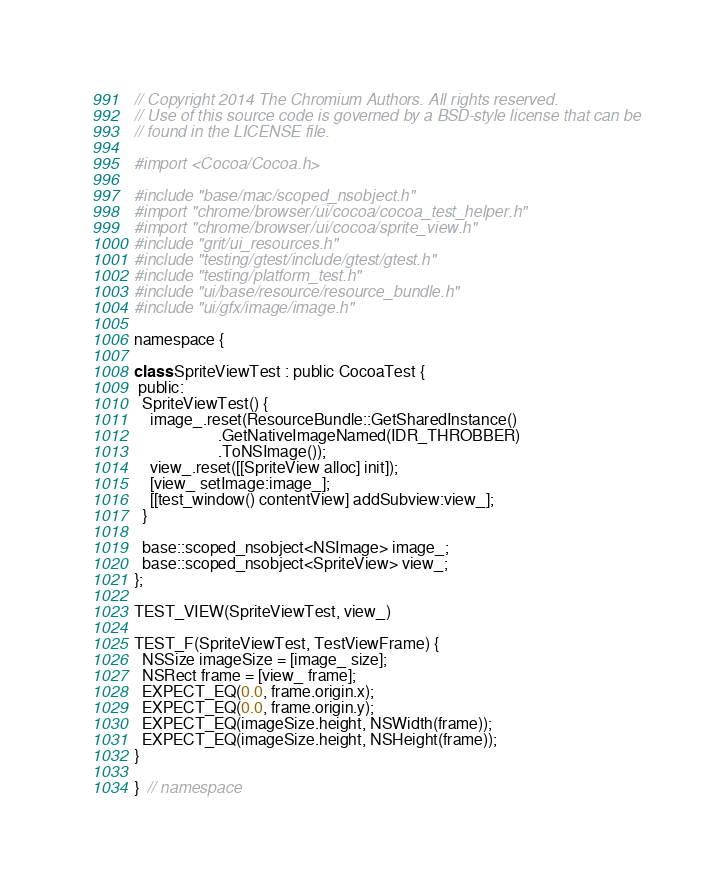Convert code to text. <code><loc_0><loc_0><loc_500><loc_500><_ObjectiveC_>// Copyright 2014 The Chromium Authors. All rights reserved.
// Use of this source code is governed by a BSD-style license that can be
// found in the LICENSE file.

#import <Cocoa/Cocoa.h>

#include "base/mac/scoped_nsobject.h"
#import "chrome/browser/ui/cocoa/cocoa_test_helper.h"
#import "chrome/browser/ui/cocoa/sprite_view.h"
#include "grit/ui_resources.h"
#include "testing/gtest/include/gtest/gtest.h"
#include "testing/platform_test.h"
#include "ui/base/resource/resource_bundle.h"
#include "ui/gfx/image/image.h"

namespace {

class SpriteViewTest : public CocoaTest {
 public:
  SpriteViewTest() {
    image_.reset(ResourceBundle::GetSharedInstance()
                     .GetNativeImageNamed(IDR_THROBBER)
                     .ToNSImage());
    view_.reset([[SpriteView alloc] init]);
    [view_ setImage:image_];
    [[test_window() contentView] addSubview:view_];
  }

  base::scoped_nsobject<NSImage> image_;
  base::scoped_nsobject<SpriteView> view_;
};

TEST_VIEW(SpriteViewTest, view_)

TEST_F(SpriteViewTest, TestViewFrame) {
  NSSize imageSize = [image_ size];
  NSRect frame = [view_ frame];
  EXPECT_EQ(0.0, frame.origin.x);
  EXPECT_EQ(0.0, frame.origin.y);
  EXPECT_EQ(imageSize.height, NSWidth(frame));
  EXPECT_EQ(imageSize.height, NSHeight(frame));
}

}  // namespace
</code> 